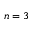<formula> <loc_0><loc_0><loc_500><loc_500>n = 3</formula> 